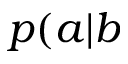<formula> <loc_0><loc_0><loc_500><loc_500>p ( a | b</formula> 